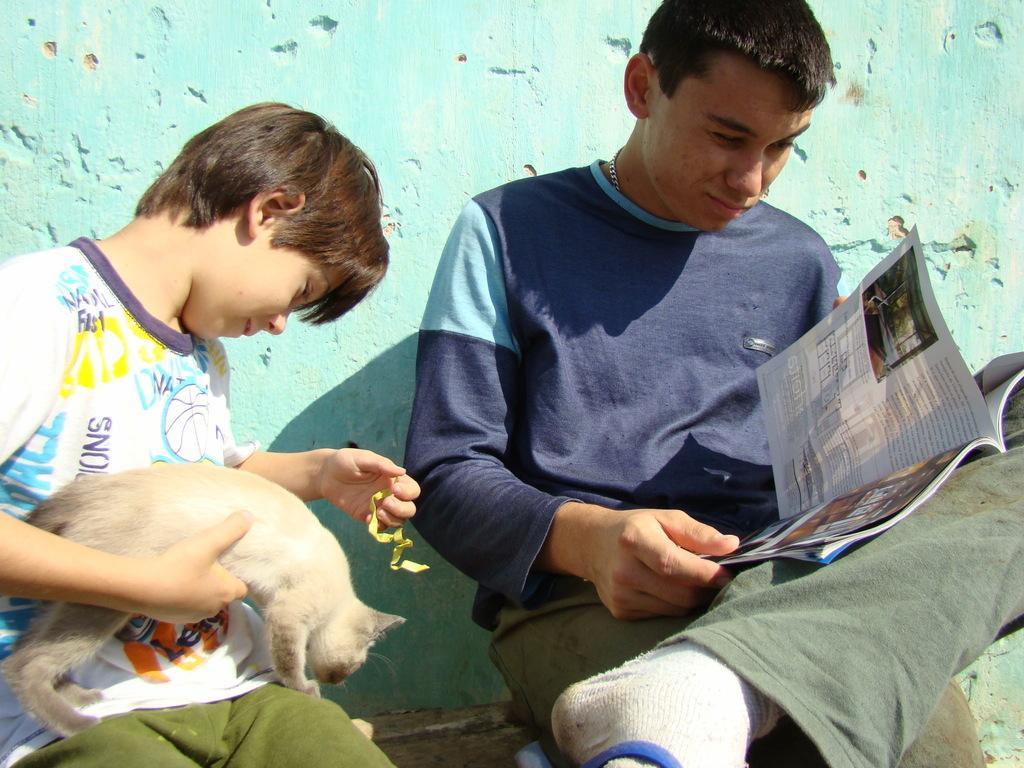In one or two sentences, can you explain what this image depicts? There are two persons in this image. One is on the right side, other is on the left side. Left side there is a kid he is holding cat in his hand. Right side there is a man he is holding a book in his hand. 